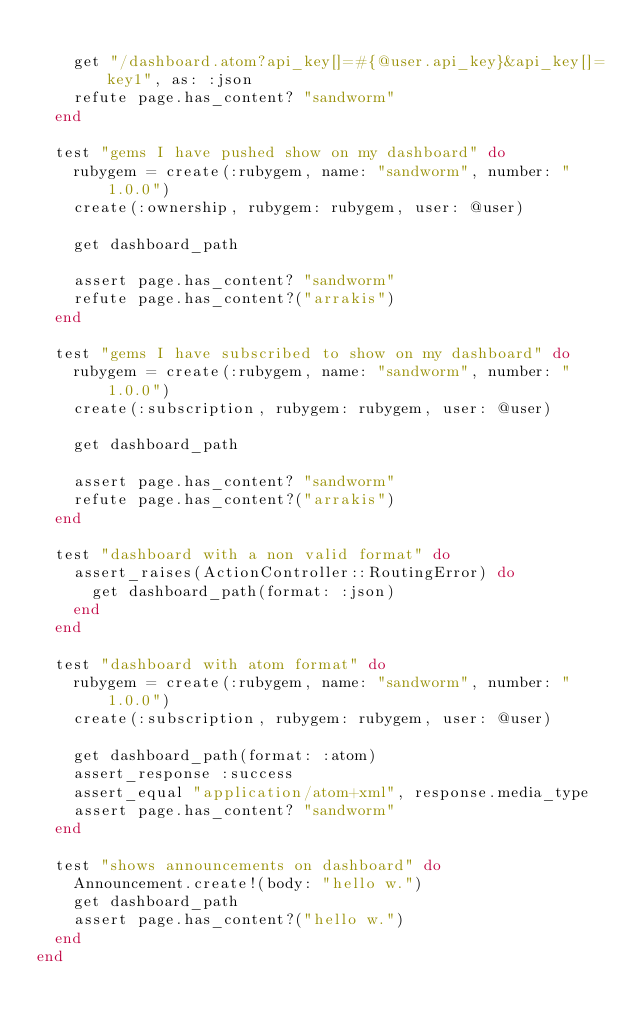Convert code to text. <code><loc_0><loc_0><loc_500><loc_500><_Ruby_>
    get "/dashboard.atom?api_key[]=#{@user.api_key}&api_key[]=key1", as: :json
    refute page.has_content? "sandworm"
  end

  test "gems I have pushed show on my dashboard" do
    rubygem = create(:rubygem, name: "sandworm", number: "1.0.0")
    create(:ownership, rubygem: rubygem, user: @user)

    get dashboard_path

    assert page.has_content? "sandworm"
    refute page.has_content?("arrakis")
  end

  test "gems I have subscribed to show on my dashboard" do
    rubygem = create(:rubygem, name: "sandworm", number: "1.0.0")
    create(:subscription, rubygem: rubygem, user: @user)

    get dashboard_path

    assert page.has_content? "sandworm"
    refute page.has_content?("arrakis")
  end

  test "dashboard with a non valid format" do
    assert_raises(ActionController::RoutingError) do
      get dashboard_path(format: :json)
    end
  end

  test "dashboard with atom format" do
    rubygem = create(:rubygem, name: "sandworm", number: "1.0.0")
    create(:subscription, rubygem: rubygem, user: @user)

    get dashboard_path(format: :atom)
    assert_response :success
    assert_equal "application/atom+xml", response.media_type
    assert page.has_content? "sandworm"
  end

  test "shows announcements on dashboard" do
    Announcement.create!(body: "hello w.")
    get dashboard_path
    assert page.has_content?("hello w.")
  end
end
</code> 